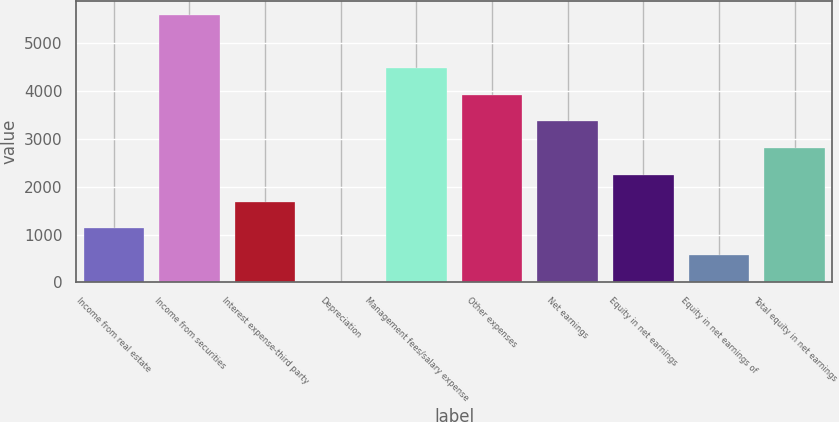Convert chart to OTSL. <chart><loc_0><loc_0><loc_500><loc_500><bar_chart><fcel>Income from real estate<fcel>Income from securities<fcel>Interest expense-third party<fcel>Depreciation<fcel>Management fees/salary expense<fcel>Other expenses<fcel>Net earnings<fcel>Equity in net earnings<fcel>Equity in net earnings of<fcel>Total equity in net earnings<nl><fcel>1131.4<fcel>5593<fcel>1689.1<fcel>16<fcel>4477.6<fcel>3919.9<fcel>3362.2<fcel>2246.8<fcel>573.7<fcel>2804.5<nl></chart> 